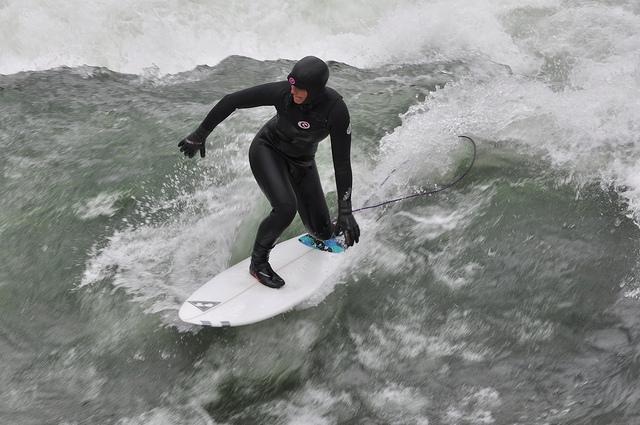What is this person doing?
Answer briefly. Surfing. What type of suit is this person wearing?
Give a very brief answer. Wetsuit. What color is the wetsuit?
Give a very brief answer. Black. 